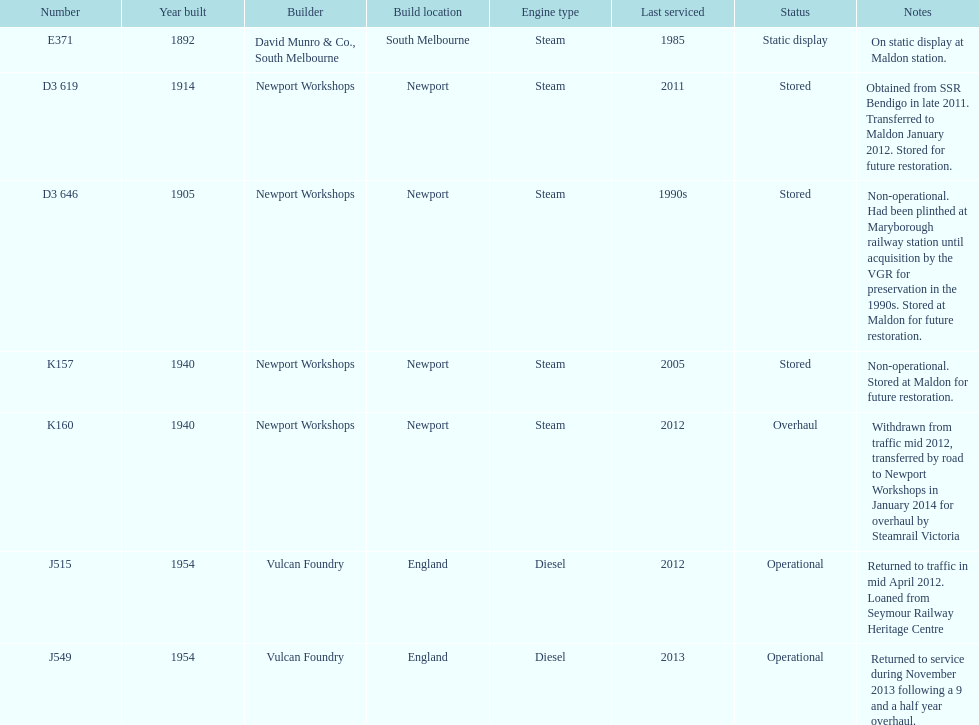How many of the locomotives were built before 1940? 3. 